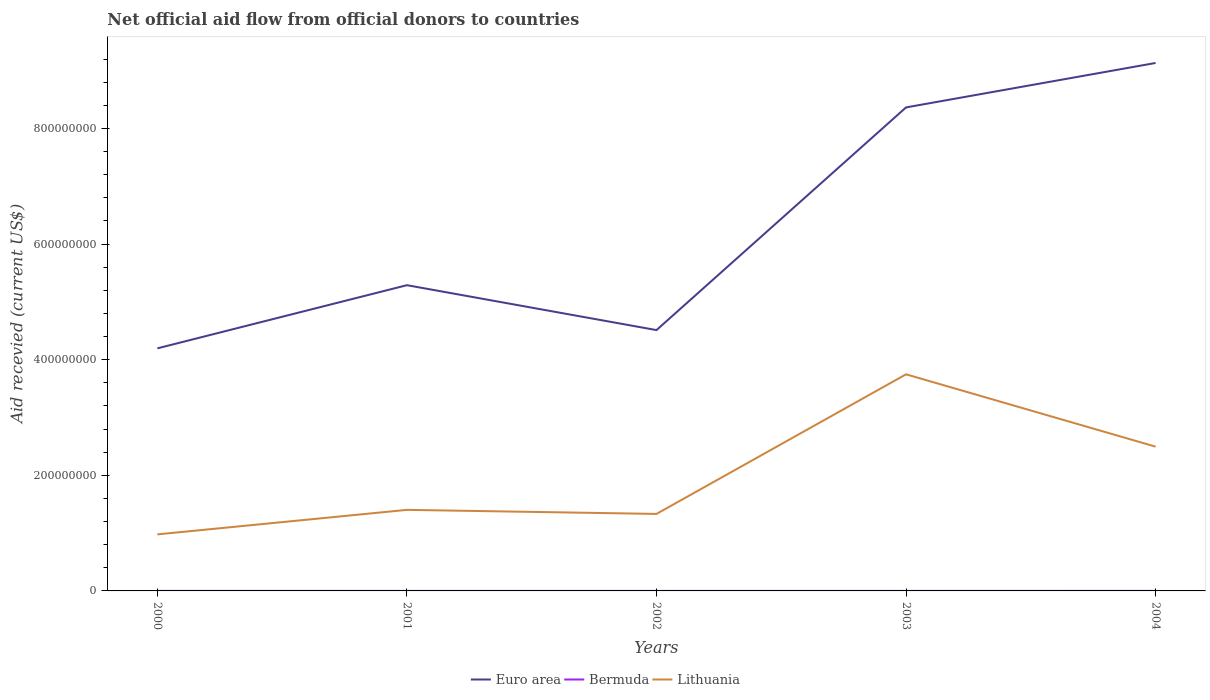How many different coloured lines are there?
Keep it short and to the point. 3. Does the line corresponding to Lithuania intersect with the line corresponding to Bermuda?
Offer a very short reply. No. Is the number of lines equal to the number of legend labels?
Your answer should be compact. Yes. Across all years, what is the maximum total aid received in Lithuania?
Keep it short and to the point. 9.78e+07. In which year was the total aid received in Bermuda maximum?
Offer a terse response. 2001. What is the total total aid received in Euro area in the graph?
Your answer should be very brief. 7.77e+07. What is the difference between the highest and the second highest total aid received in Bermuda?
Your answer should be very brief. 7.00e+04. What is the difference between the highest and the lowest total aid received in Bermuda?
Provide a succinct answer. 2. How many lines are there?
Your answer should be very brief. 3. How many years are there in the graph?
Give a very brief answer. 5. What is the difference between two consecutive major ticks on the Y-axis?
Ensure brevity in your answer.  2.00e+08. Does the graph contain any zero values?
Offer a terse response. No. Does the graph contain grids?
Keep it short and to the point. No. Where does the legend appear in the graph?
Give a very brief answer. Bottom center. How many legend labels are there?
Your answer should be very brief. 3. How are the legend labels stacked?
Offer a very short reply. Horizontal. What is the title of the graph?
Make the answer very short. Net official aid flow from official donors to countries. What is the label or title of the X-axis?
Your answer should be very brief. Years. What is the label or title of the Y-axis?
Give a very brief answer. Aid recevied (current US$). What is the Aid recevied (current US$) of Euro area in 2000?
Offer a terse response. 4.20e+08. What is the Aid recevied (current US$) in Bermuda in 2000?
Your answer should be very brief. 6.00e+04. What is the Aid recevied (current US$) of Lithuania in 2000?
Give a very brief answer. 9.78e+07. What is the Aid recevied (current US$) of Euro area in 2001?
Your answer should be very brief. 5.29e+08. What is the Aid recevied (current US$) of Bermuda in 2001?
Offer a terse response. 2.00e+04. What is the Aid recevied (current US$) in Lithuania in 2001?
Ensure brevity in your answer.  1.40e+08. What is the Aid recevied (current US$) in Euro area in 2002?
Offer a terse response. 4.51e+08. What is the Aid recevied (current US$) of Lithuania in 2002?
Keep it short and to the point. 1.33e+08. What is the Aid recevied (current US$) in Euro area in 2003?
Your answer should be very brief. 8.36e+08. What is the Aid recevied (current US$) in Bermuda in 2003?
Your response must be concise. 3.00e+04. What is the Aid recevied (current US$) in Lithuania in 2003?
Offer a very short reply. 3.75e+08. What is the Aid recevied (current US$) in Euro area in 2004?
Provide a succinct answer. 9.13e+08. What is the Aid recevied (current US$) in Lithuania in 2004?
Offer a terse response. 2.50e+08. Across all years, what is the maximum Aid recevied (current US$) in Euro area?
Offer a terse response. 9.13e+08. Across all years, what is the maximum Aid recevied (current US$) in Bermuda?
Your response must be concise. 9.00e+04. Across all years, what is the maximum Aid recevied (current US$) in Lithuania?
Offer a very short reply. 3.75e+08. Across all years, what is the minimum Aid recevied (current US$) of Euro area?
Provide a succinct answer. 4.20e+08. Across all years, what is the minimum Aid recevied (current US$) in Lithuania?
Ensure brevity in your answer.  9.78e+07. What is the total Aid recevied (current US$) of Euro area in the graph?
Offer a terse response. 3.15e+09. What is the total Aid recevied (current US$) of Lithuania in the graph?
Offer a very short reply. 9.96e+08. What is the difference between the Aid recevied (current US$) of Euro area in 2000 and that in 2001?
Make the answer very short. -1.09e+08. What is the difference between the Aid recevied (current US$) of Lithuania in 2000 and that in 2001?
Give a very brief answer. -4.24e+07. What is the difference between the Aid recevied (current US$) in Euro area in 2000 and that in 2002?
Offer a terse response. -3.16e+07. What is the difference between the Aid recevied (current US$) in Bermuda in 2000 and that in 2002?
Offer a terse response. 4.00e+04. What is the difference between the Aid recevied (current US$) in Lithuania in 2000 and that in 2002?
Offer a terse response. -3.54e+07. What is the difference between the Aid recevied (current US$) of Euro area in 2000 and that in 2003?
Make the answer very short. -4.17e+08. What is the difference between the Aid recevied (current US$) of Lithuania in 2000 and that in 2003?
Provide a succinct answer. -2.77e+08. What is the difference between the Aid recevied (current US$) in Euro area in 2000 and that in 2004?
Offer a terse response. -4.94e+08. What is the difference between the Aid recevied (current US$) of Bermuda in 2000 and that in 2004?
Give a very brief answer. -3.00e+04. What is the difference between the Aid recevied (current US$) of Lithuania in 2000 and that in 2004?
Offer a terse response. -1.52e+08. What is the difference between the Aid recevied (current US$) of Euro area in 2001 and that in 2002?
Provide a succinct answer. 7.77e+07. What is the difference between the Aid recevied (current US$) of Bermuda in 2001 and that in 2002?
Your answer should be very brief. 0. What is the difference between the Aid recevied (current US$) of Lithuania in 2001 and that in 2002?
Your answer should be compact. 7.02e+06. What is the difference between the Aid recevied (current US$) in Euro area in 2001 and that in 2003?
Ensure brevity in your answer.  -3.08e+08. What is the difference between the Aid recevied (current US$) in Bermuda in 2001 and that in 2003?
Provide a short and direct response. -10000. What is the difference between the Aid recevied (current US$) of Lithuania in 2001 and that in 2003?
Ensure brevity in your answer.  -2.34e+08. What is the difference between the Aid recevied (current US$) in Euro area in 2001 and that in 2004?
Keep it short and to the point. -3.84e+08. What is the difference between the Aid recevied (current US$) of Lithuania in 2001 and that in 2004?
Keep it short and to the point. -1.09e+08. What is the difference between the Aid recevied (current US$) in Euro area in 2002 and that in 2003?
Offer a very short reply. -3.85e+08. What is the difference between the Aid recevied (current US$) in Lithuania in 2002 and that in 2003?
Provide a short and direct response. -2.41e+08. What is the difference between the Aid recevied (current US$) in Euro area in 2002 and that in 2004?
Ensure brevity in your answer.  -4.62e+08. What is the difference between the Aid recevied (current US$) of Lithuania in 2002 and that in 2004?
Ensure brevity in your answer.  -1.16e+08. What is the difference between the Aid recevied (current US$) in Euro area in 2003 and that in 2004?
Your answer should be very brief. -7.69e+07. What is the difference between the Aid recevied (current US$) of Lithuania in 2003 and that in 2004?
Make the answer very short. 1.25e+08. What is the difference between the Aid recevied (current US$) in Euro area in 2000 and the Aid recevied (current US$) in Bermuda in 2001?
Ensure brevity in your answer.  4.20e+08. What is the difference between the Aid recevied (current US$) of Euro area in 2000 and the Aid recevied (current US$) of Lithuania in 2001?
Keep it short and to the point. 2.79e+08. What is the difference between the Aid recevied (current US$) of Bermuda in 2000 and the Aid recevied (current US$) of Lithuania in 2001?
Give a very brief answer. -1.40e+08. What is the difference between the Aid recevied (current US$) of Euro area in 2000 and the Aid recevied (current US$) of Bermuda in 2002?
Give a very brief answer. 4.20e+08. What is the difference between the Aid recevied (current US$) in Euro area in 2000 and the Aid recevied (current US$) in Lithuania in 2002?
Your answer should be compact. 2.86e+08. What is the difference between the Aid recevied (current US$) of Bermuda in 2000 and the Aid recevied (current US$) of Lithuania in 2002?
Offer a terse response. -1.33e+08. What is the difference between the Aid recevied (current US$) in Euro area in 2000 and the Aid recevied (current US$) in Bermuda in 2003?
Make the answer very short. 4.20e+08. What is the difference between the Aid recevied (current US$) of Euro area in 2000 and the Aid recevied (current US$) of Lithuania in 2003?
Ensure brevity in your answer.  4.49e+07. What is the difference between the Aid recevied (current US$) of Bermuda in 2000 and the Aid recevied (current US$) of Lithuania in 2003?
Offer a very short reply. -3.75e+08. What is the difference between the Aid recevied (current US$) in Euro area in 2000 and the Aid recevied (current US$) in Bermuda in 2004?
Ensure brevity in your answer.  4.20e+08. What is the difference between the Aid recevied (current US$) in Euro area in 2000 and the Aid recevied (current US$) in Lithuania in 2004?
Offer a very short reply. 1.70e+08. What is the difference between the Aid recevied (current US$) of Bermuda in 2000 and the Aid recevied (current US$) of Lithuania in 2004?
Your answer should be compact. -2.50e+08. What is the difference between the Aid recevied (current US$) of Euro area in 2001 and the Aid recevied (current US$) of Bermuda in 2002?
Your response must be concise. 5.29e+08. What is the difference between the Aid recevied (current US$) of Euro area in 2001 and the Aid recevied (current US$) of Lithuania in 2002?
Ensure brevity in your answer.  3.96e+08. What is the difference between the Aid recevied (current US$) in Bermuda in 2001 and the Aid recevied (current US$) in Lithuania in 2002?
Your answer should be very brief. -1.33e+08. What is the difference between the Aid recevied (current US$) in Euro area in 2001 and the Aid recevied (current US$) in Bermuda in 2003?
Your response must be concise. 5.29e+08. What is the difference between the Aid recevied (current US$) of Euro area in 2001 and the Aid recevied (current US$) of Lithuania in 2003?
Provide a short and direct response. 1.54e+08. What is the difference between the Aid recevied (current US$) in Bermuda in 2001 and the Aid recevied (current US$) in Lithuania in 2003?
Provide a short and direct response. -3.75e+08. What is the difference between the Aid recevied (current US$) in Euro area in 2001 and the Aid recevied (current US$) in Bermuda in 2004?
Give a very brief answer. 5.29e+08. What is the difference between the Aid recevied (current US$) in Euro area in 2001 and the Aid recevied (current US$) in Lithuania in 2004?
Keep it short and to the point. 2.79e+08. What is the difference between the Aid recevied (current US$) of Bermuda in 2001 and the Aid recevied (current US$) of Lithuania in 2004?
Offer a terse response. -2.50e+08. What is the difference between the Aid recevied (current US$) of Euro area in 2002 and the Aid recevied (current US$) of Bermuda in 2003?
Offer a terse response. 4.51e+08. What is the difference between the Aid recevied (current US$) of Euro area in 2002 and the Aid recevied (current US$) of Lithuania in 2003?
Give a very brief answer. 7.65e+07. What is the difference between the Aid recevied (current US$) in Bermuda in 2002 and the Aid recevied (current US$) in Lithuania in 2003?
Keep it short and to the point. -3.75e+08. What is the difference between the Aid recevied (current US$) in Euro area in 2002 and the Aid recevied (current US$) in Bermuda in 2004?
Keep it short and to the point. 4.51e+08. What is the difference between the Aid recevied (current US$) in Euro area in 2002 and the Aid recevied (current US$) in Lithuania in 2004?
Ensure brevity in your answer.  2.02e+08. What is the difference between the Aid recevied (current US$) of Bermuda in 2002 and the Aid recevied (current US$) of Lithuania in 2004?
Provide a succinct answer. -2.50e+08. What is the difference between the Aid recevied (current US$) in Euro area in 2003 and the Aid recevied (current US$) in Bermuda in 2004?
Your response must be concise. 8.36e+08. What is the difference between the Aid recevied (current US$) in Euro area in 2003 and the Aid recevied (current US$) in Lithuania in 2004?
Offer a terse response. 5.87e+08. What is the difference between the Aid recevied (current US$) of Bermuda in 2003 and the Aid recevied (current US$) of Lithuania in 2004?
Offer a terse response. -2.50e+08. What is the average Aid recevied (current US$) in Euro area per year?
Provide a succinct answer. 6.30e+08. What is the average Aid recevied (current US$) in Bermuda per year?
Keep it short and to the point. 4.40e+04. What is the average Aid recevied (current US$) in Lithuania per year?
Offer a terse response. 1.99e+08. In the year 2000, what is the difference between the Aid recevied (current US$) of Euro area and Aid recevied (current US$) of Bermuda?
Give a very brief answer. 4.20e+08. In the year 2000, what is the difference between the Aid recevied (current US$) in Euro area and Aid recevied (current US$) in Lithuania?
Keep it short and to the point. 3.22e+08. In the year 2000, what is the difference between the Aid recevied (current US$) of Bermuda and Aid recevied (current US$) of Lithuania?
Your answer should be compact. -9.78e+07. In the year 2001, what is the difference between the Aid recevied (current US$) of Euro area and Aid recevied (current US$) of Bermuda?
Offer a terse response. 5.29e+08. In the year 2001, what is the difference between the Aid recevied (current US$) in Euro area and Aid recevied (current US$) in Lithuania?
Keep it short and to the point. 3.89e+08. In the year 2001, what is the difference between the Aid recevied (current US$) of Bermuda and Aid recevied (current US$) of Lithuania?
Your response must be concise. -1.40e+08. In the year 2002, what is the difference between the Aid recevied (current US$) in Euro area and Aid recevied (current US$) in Bermuda?
Offer a very short reply. 4.51e+08. In the year 2002, what is the difference between the Aid recevied (current US$) in Euro area and Aid recevied (current US$) in Lithuania?
Offer a terse response. 3.18e+08. In the year 2002, what is the difference between the Aid recevied (current US$) in Bermuda and Aid recevied (current US$) in Lithuania?
Your answer should be very brief. -1.33e+08. In the year 2003, what is the difference between the Aid recevied (current US$) in Euro area and Aid recevied (current US$) in Bermuda?
Offer a very short reply. 8.36e+08. In the year 2003, what is the difference between the Aid recevied (current US$) in Euro area and Aid recevied (current US$) in Lithuania?
Offer a terse response. 4.62e+08. In the year 2003, what is the difference between the Aid recevied (current US$) in Bermuda and Aid recevied (current US$) in Lithuania?
Your response must be concise. -3.75e+08. In the year 2004, what is the difference between the Aid recevied (current US$) in Euro area and Aid recevied (current US$) in Bermuda?
Your response must be concise. 9.13e+08. In the year 2004, what is the difference between the Aid recevied (current US$) of Euro area and Aid recevied (current US$) of Lithuania?
Keep it short and to the point. 6.64e+08. In the year 2004, what is the difference between the Aid recevied (current US$) in Bermuda and Aid recevied (current US$) in Lithuania?
Your response must be concise. -2.49e+08. What is the ratio of the Aid recevied (current US$) of Euro area in 2000 to that in 2001?
Provide a succinct answer. 0.79. What is the ratio of the Aid recevied (current US$) of Bermuda in 2000 to that in 2001?
Your answer should be very brief. 3. What is the ratio of the Aid recevied (current US$) of Lithuania in 2000 to that in 2001?
Your response must be concise. 0.7. What is the ratio of the Aid recevied (current US$) of Euro area in 2000 to that in 2002?
Provide a succinct answer. 0.93. What is the ratio of the Aid recevied (current US$) in Bermuda in 2000 to that in 2002?
Make the answer very short. 3. What is the ratio of the Aid recevied (current US$) in Lithuania in 2000 to that in 2002?
Make the answer very short. 0.73. What is the ratio of the Aid recevied (current US$) of Euro area in 2000 to that in 2003?
Offer a terse response. 0.5. What is the ratio of the Aid recevied (current US$) of Lithuania in 2000 to that in 2003?
Your response must be concise. 0.26. What is the ratio of the Aid recevied (current US$) of Euro area in 2000 to that in 2004?
Keep it short and to the point. 0.46. What is the ratio of the Aid recevied (current US$) in Lithuania in 2000 to that in 2004?
Ensure brevity in your answer.  0.39. What is the ratio of the Aid recevied (current US$) of Euro area in 2001 to that in 2002?
Offer a very short reply. 1.17. What is the ratio of the Aid recevied (current US$) in Bermuda in 2001 to that in 2002?
Offer a terse response. 1. What is the ratio of the Aid recevied (current US$) in Lithuania in 2001 to that in 2002?
Ensure brevity in your answer.  1.05. What is the ratio of the Aid recevied (current US$) in Euro area in 2001 to that in 2003?
Make the answer very short. 0.63. What is the ratio of the Aid recevied (current US$) in Bermuda in 2001 to that in 2003?
Offer a very short reply. 0.67. What is the ratio of the Aid recevied (current US$) of Lithuania in 2001 to that in 2003?
Offer a terse response. 0.37. What is the ratio of the Aid recevied (current US$) in Euro area in 2001 to that in 2004?
Give a very brief answer. 0.58. What is the ratio of the Aid recevied (current US$) in Bermuda in 2001 to that in 2004?
Your response must be concise. 0.22. What is the ratio of the Aid recevied (current US$) of Lithuania in 2001 to that in 2004?
Make the answer very short. 0.56. What is the ratio of the Aid recevied (current US$) in Euro area in 2002 to that in 2003?
Your answer should be compact. 0.54. What is the ratio of the Aid recevied (current US$) in Bermuda in 2002 to that in 2003?
Provide a succinct answer. 0.67. What is the ratio of the Aid recevied (current US$) of Lithuania in 2002 to that in 2003?
Offer a very short reply. 0.36. What is the ratio of the Aid recevied (current US$) of Euro area in 2002 to that in 2004?
Offer a terse response. 0.49. What is the ratio of the Aid recevied (current US$) in Bermuda in 2002 to that in 2004?
Offer a terse response. 0.22. What is the ratio of the Aid recevied (current US$) of Lithuania in 2002 to that in 2004?
Offer a very short reply. 0.53. What is the ratio of the Aid recevied (current US$) of Euro area in 2003 to that in 2004?
Provide a succinct answer. 0.92. What is the ratio of the Aid recevied (current US$) in Bermuda in 2003 to that in 2004?
Offer a very short reply. 0.33. What is the ratio of the Aid recevied (current US$) in Lithuania in 2003 to that in 2004?
Give a very brief answer. 1.5. What is the difference between the highest and the second highest Aid recevied (current US$) in Euro area?
Provide a succinct answer. 7.69e+07. What is the difference between the highest and the second highest Aid recevied (current US$) in Lithuania?
Make the answer very short. 1.25e+08. What is the difference between the highest and the lowest Aid recevied (current US$) in Euro area?
Keep it short and to the point. 4.94e+08. What is the difference between the highest and the lowest Aid recevied (current US$) of Bermuda?
Offer a very short reply. 7.00e+04. What is the difference between the highest and the lowest Aid recevied (current US$) of Lithuania?
Offer a terse response. 2.77e+08. 